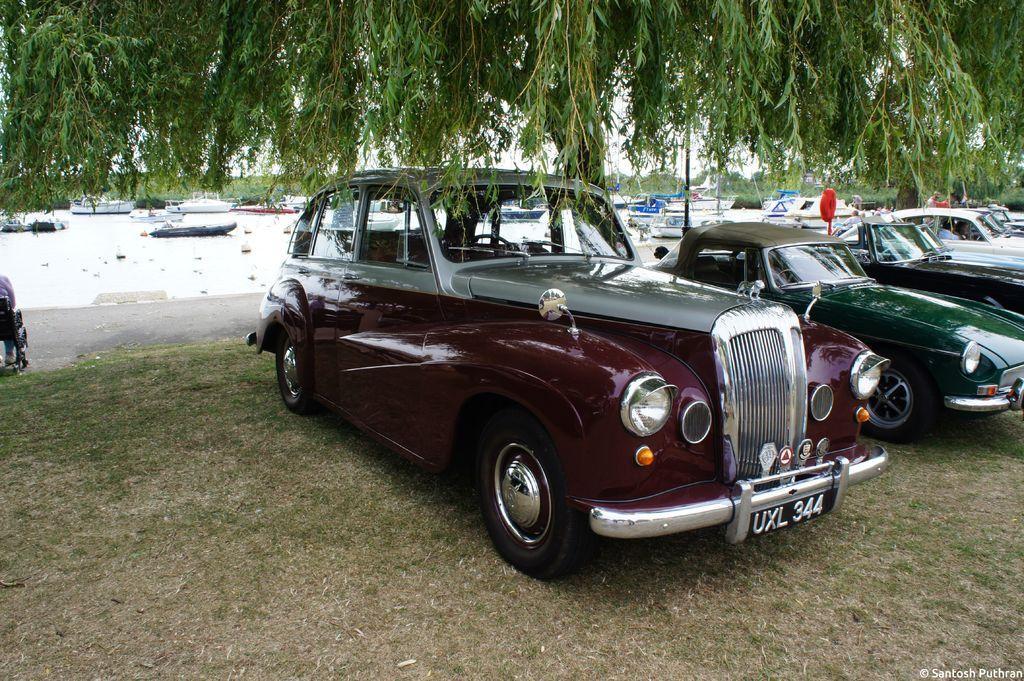Please provide a concise description of this image. In this image we can see few trees and vehicles on the ground, in the background there are some boats on the water. 